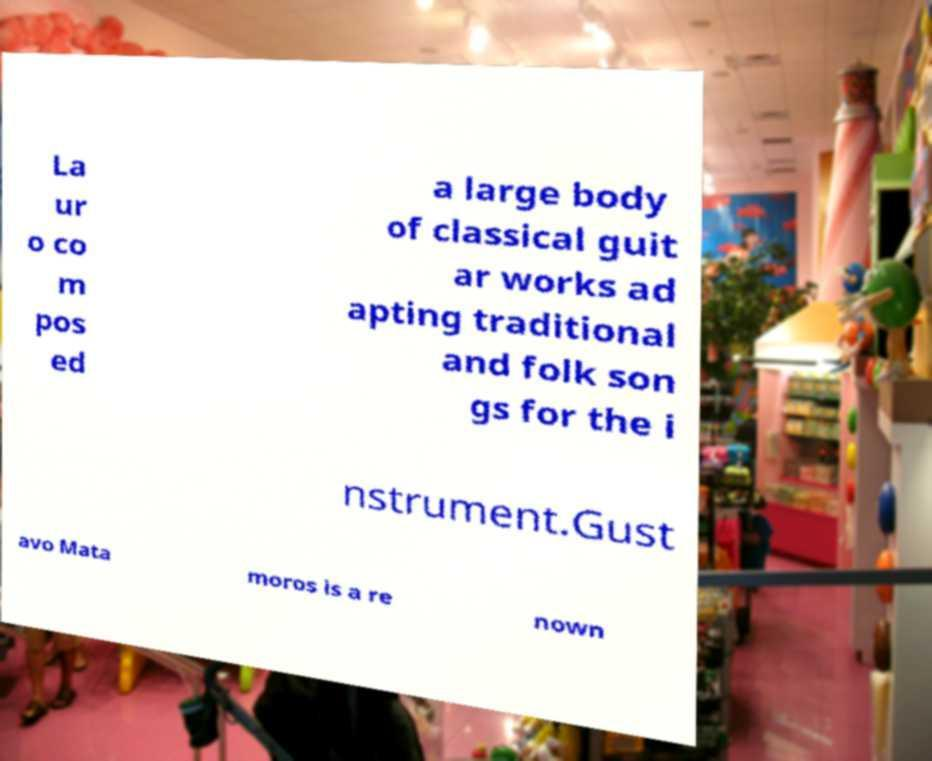Please identify and transcribe the text found in this image. La ur o co m pos ed a large body of classical guit ar works ad apting traditional and folk son gs for the i nstrument.Gust avo Mata moros is a re nown 